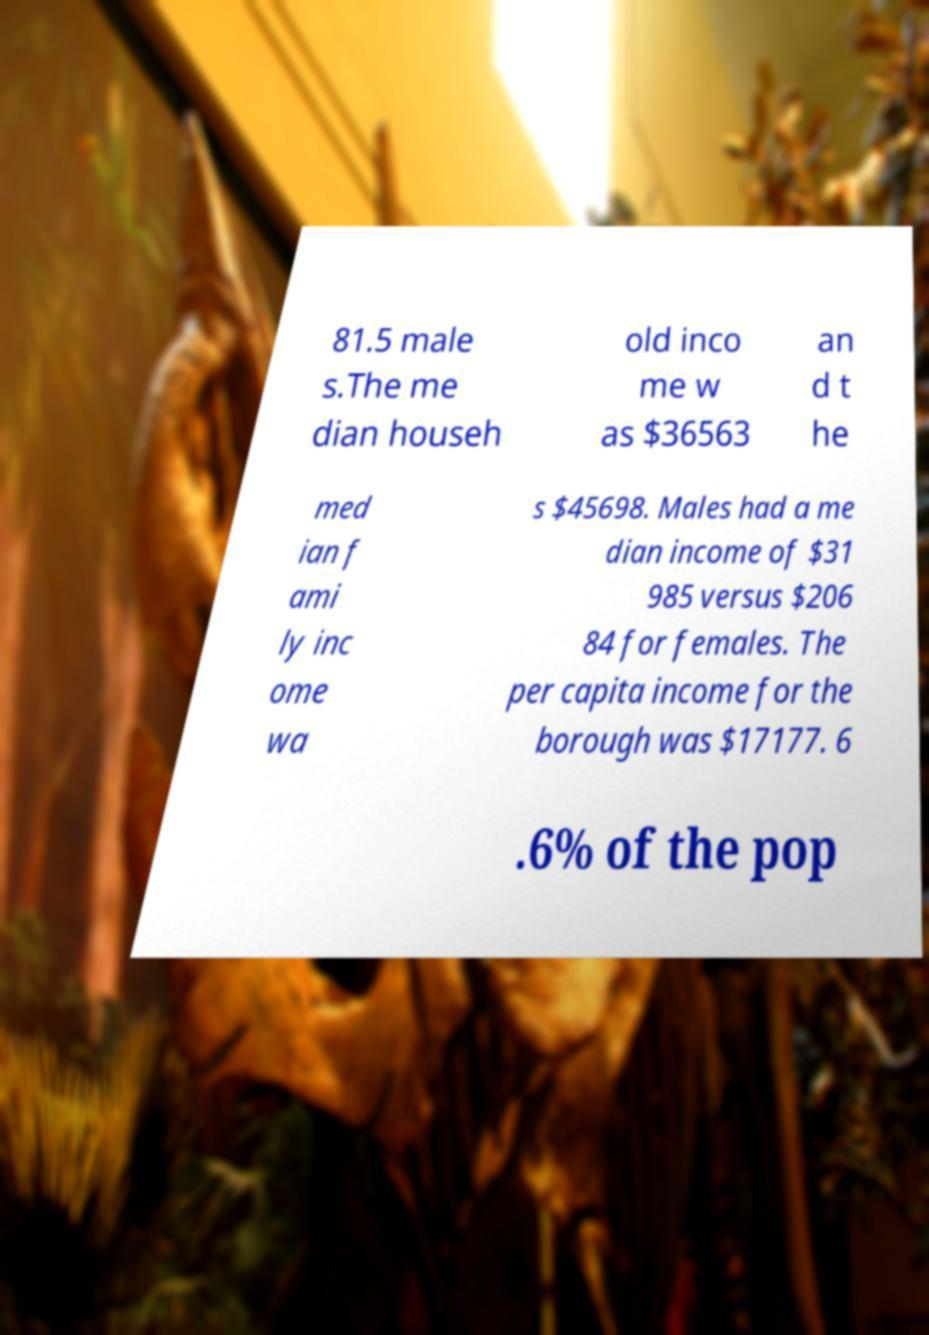Could you extract and type out the text from this image? 81.5 male s.The me dian househ old inco me w as $36563 an d t he med ian f ami ly inc ome wa s $45698. Males had a me dian income of $31 985 versus $206 84 for females. The per capita income for the borough was $17177. 6 .6% of the pop 